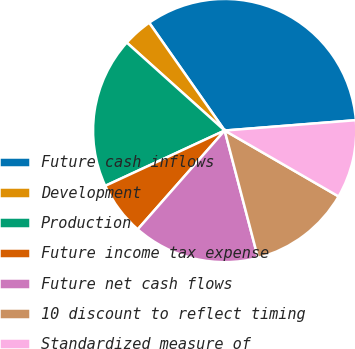Convert chart. <chart><loc_0><loc_0><loc_500><loc_500><pie_chart><fcel>Future cash inflows<fcel>Development<fcel>Production<fcel>Future income tax expense<fcel>Future net cash flows<fcel>10 discount to reflect timing<fcel>Standardized measure of<nl><fcel>33.47%<fcel>3.63%<fcel>18.55%<fcel>6.61%<fcel>15.56%<fcel>12.58%<fcel>9.6%<nl></chart> 